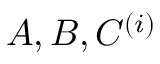Convert formula to latex. <formula><loc_0><loc_0><loc_500><loc_500>A , B , C ^ { ( i ) }</formula> 